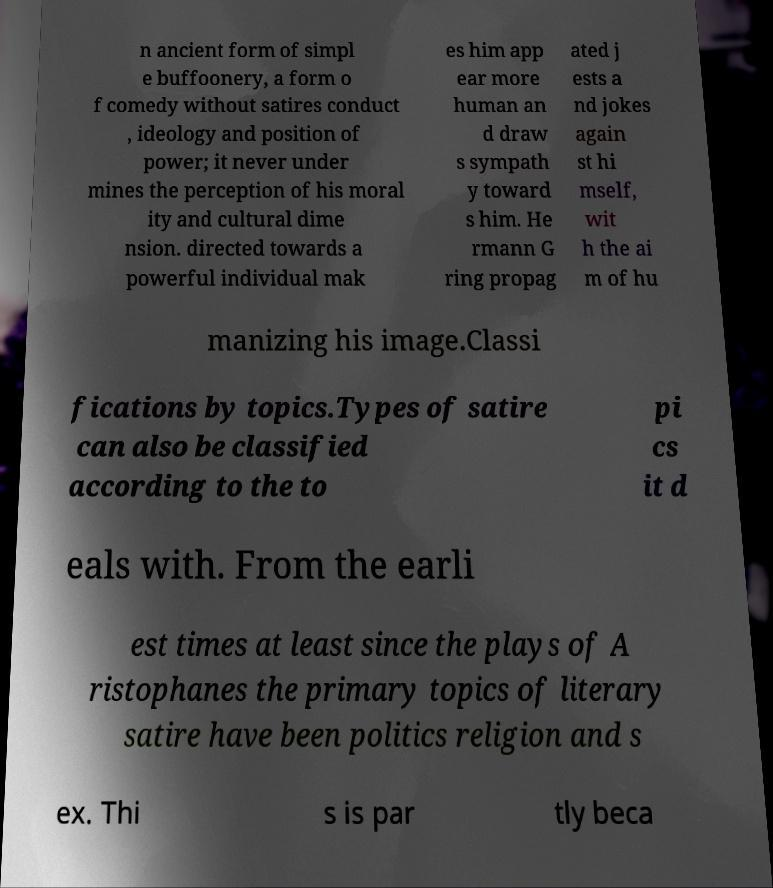I need the written content from this picture converted into text. Can you do that? n ancient form of simpl e buffoonery, a form o f comedy without satires conduct , ideology and position of power; it never under mines the perception of his moral ity and cultural dime nsion. directed towards a powerful individual mak es him app ear more human an d draw s sympath y toward s him. He rmann G ring propag ated j ests a nd jokes again st hi mself, wit h the ai m of hu manizing his image.Classi fications by topics.Types of satire can also be classified according to the to pi cs it d eals with. From the earli est times at least since the plays of A ristophanes the primary topics of literary satire have been politics religion and s ex. Thi s is par tly beca 